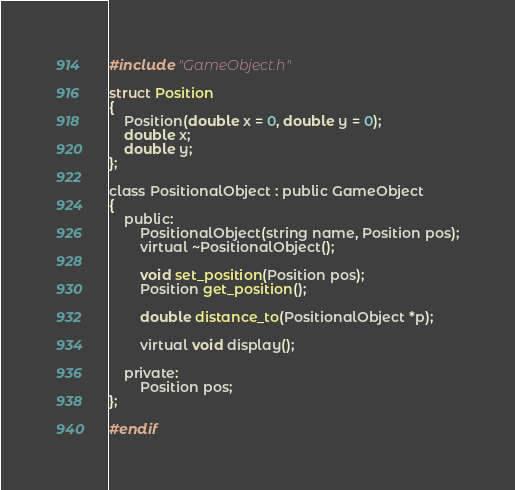Convert code to text. <code><loc_0><loc_0><loc_500><loc_500><_C_>
#include "GameObject.h"

struct Position
{
	Position(double x = 0, double y = 0);
	double x;
	double y;
};

class PositionalObject : public GameObject
{
	public:
		PositionalObject(string name, Position pos);
		virtual ~PositionalObject();

		void set_position(Position pos);
		Position get_position();

		double distance_to(PositionalObject *p);

		virtual void display();

	private:
		Position pos;
};

#endif
</code> 